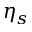<formula> <loc_0><loc_0><loc_500><loc_500>\eta _ { s }</formula> 